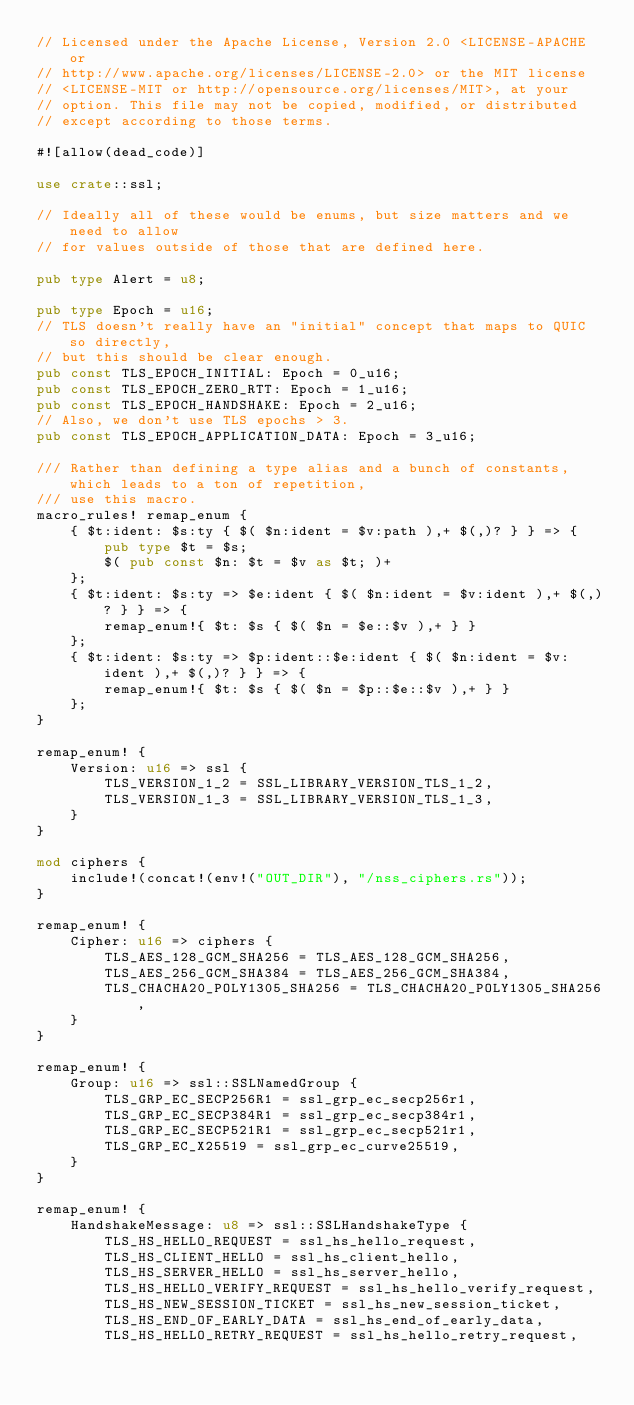<code> <loc_0><loc_0><loc_500><loc_500><_Rust_>// Licensed under the Apache License, Version 2.0 <LICENSE-APACHE or
// http://www.apache.org/licenses/LICENSE-2.0> or the MIT license
// <LICENSE-MIT or http://opensource.org/licenses/MIT>, at your
// option. This file may not be copied, modified, or distributed
// except according to those terms.

#![allow(dead_code)]

use crate::ssl;

// Ideally all of these would be enums, but size matters and we need to allow
// for values outside of those that are defined here.

pub type Alert = u8;

pub type Epoch = u16;
// TLS doesn't really have an "initial" concept that maps to QUIC so directly,
// but this should be clear enough.
pub const TLS_EPOCH_INITIAL: Epoch = 0_u16;
pub const TLS_EPOCH_ZERO_RTT: Epoch = 1_u16;
pub const TLS_EPOCH_HANDSHAKE: Epoch = 2_u16;
// Also, we don't use TLS epochs > 3.
pub const TLS_EPOCH_APPLICATION_DATA: Epoch = 3_u16;

/// Rather than defining a type alias and a bunch of constants, which leads to a ton of repetition,
/// use this macro.
macro_rules! remap_enum {
    { $t:ident: $s:ty { $( $n:ident = $v:path ),+ $(,)? } } => {
        pub type $t = $s;
        $( pub const $n: $t = $v as $t; )+
    };
    { $t:ident: $s:ty => $e:ident { $( $n:ident = $v:ident ),+ $(,)? } } => {
        remap_enum!{ $t: $s { $( $n = $e::$v ),+ } }
    };
    { $t:ident: $s:ty => $p:ident::$e:ident { $( $n:ident = $v:ident ),+ $(,)? } } => {
        remap_enum!{ $t: $s { $( $n = $p::$e::$v ),+ } }
    };
}

remap_enum! {
    Version: u16 => ssl {
        TLS_VERSION_1_2 = SSL_LIBRARY_VERSION_TLS_1_2,
        TLS_VERSION_1_3 = SSL_LIBRARY_VERSION_TLS_1_3,
    }
}

mod ciphers {
    include!(concat!(env!("OUT_DIR"), "/nss_ciphers.rs"));
}

remap_enum! {
    Cipher: u16 => ciphers {
        TLS_AES_128_GCM_SHA256 = TLS_AES_128_GCM_SHA256,
        TLS_AES_256_GCM_SHA384 = TLS_AES_256_GCM_SHA384,
        TLS_CHACHA20_POLY1305_SHA256 = TLS_CHACHA20_POLY1305_SHA256,
    }
}

remap_enum! {
    Group: u16 => ssl::SSLNamedGroup {
        TLS_GRP_EC_SECP256R1 = ssl_grp_ec_secp256r1,
        TLS_GRP_EC_SECP384R1 = ssl_grp_ec_secp384r1,
        TLS_GRP_EC_SECP521R1 = ssl_grp_ec_secp521r1,
        TLS_GRP_EC_X25519 = ssl_grp_ec_curve25519,
    }
}

remap_enum! {
    HandshakeMessage: u8 => ssl::SSLHandshakeType {
        TLS_HS_HELLO_REQUEST = ssl_hs_hello_request,
        TLS_HS_CLIENT_HELLO = ssl_hs_client_hello,
        TLS_HS_SERVER_HELLO = ssl_hs_server_hello,
        TLS_HS_HELLO_VERIFY_REQUEST = ssl_hs_hello_verify_request,
        TLS_HS_NEW_SESSION_TICKET = ssl_hs_new_session_ticket,
        TLS_HS_END_OF_EARLY_DATA = ssl_hs_end_of_early_data,
        TLS_HS_HELLO_RETRY_REQUEST = ssl_hs_hello_retry_request,</code> 